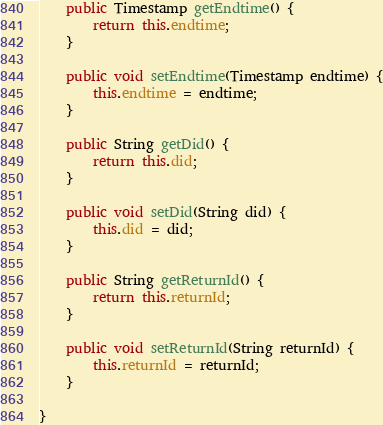Convert code to text. <code><loc_0><loc_0><loc_500><loc_500><_Java_>	public Timestamp getEndtime() {
		return this.endtime;
	}

	public void setEndtime(Timestamp endtime) {
		this.endtime = endtime;
	}

	public String getDid() {
		return this.did;
	}

	public void setDid(String did) {
		this.did = did;
	}

	public String getReturnId() {
		return this.returnId;
	}

	public void setReturnId(String returnId) {
		this.returnId = returnId;
	}

}</code> 